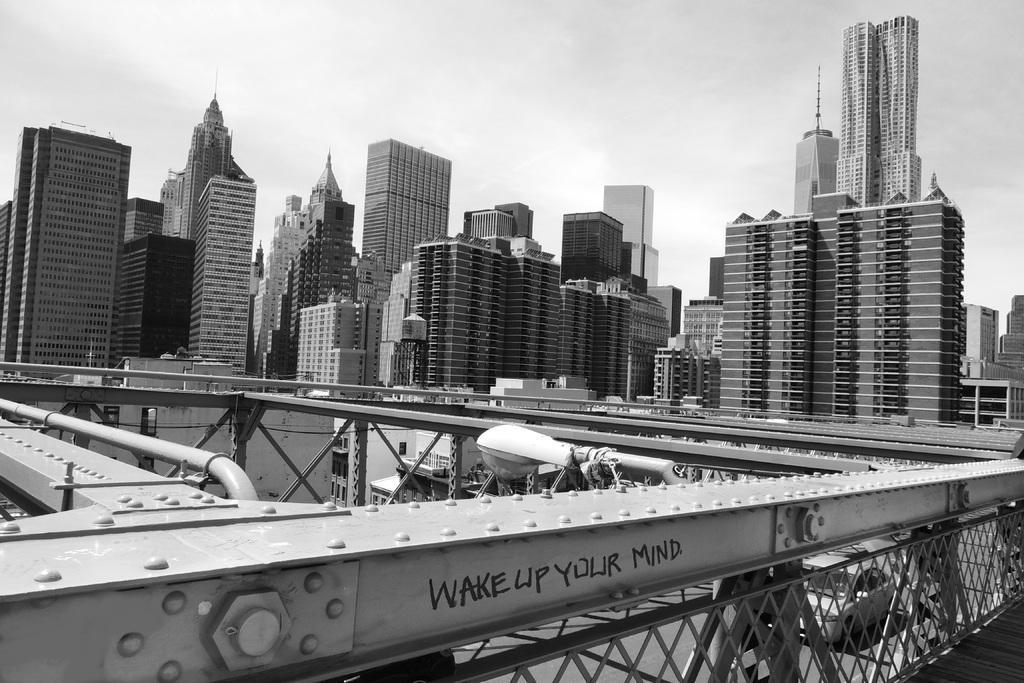Describe this image in one or two sentences. This is a black and white image. I can see the buildings and a street light. At the bottom of the image, there is a car on the road, which is behind the iron fence. In the background, I can see the sky. 